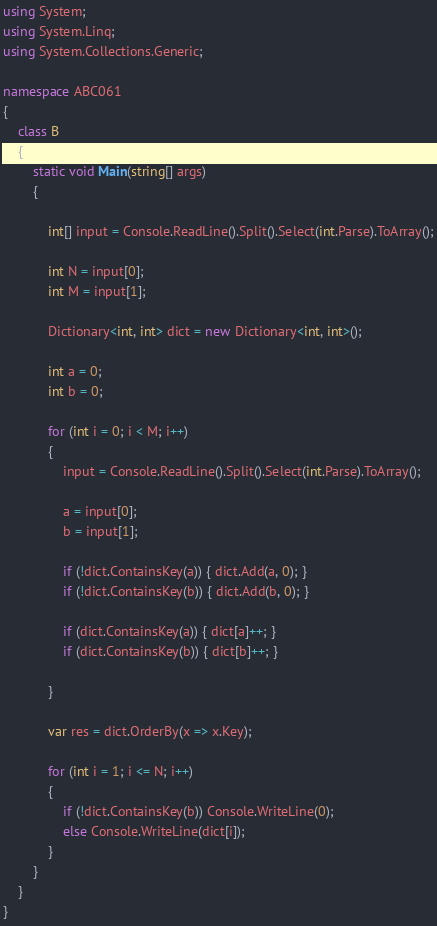<code> <loc_0><loc_0><loc_500><loc_500><_C#_>using System;
using System.Linq;
using System.Collections.Generic;

namespace ABC061
{
    class B
    {
        static void Main(string[] args)
        {

            int[] input = Console.ReadLine().Split().Select(int.Parse).ToArray();

            int N = input[0];
            int M = input[1];

            Dictionary<int, int> dict = new Dictionary<int, int>();

            int a = 0;
            int b = 0;

            for (int i = 0; i < M; i++)
            {
                input = Console.ReadLine().Split().Select(int.Parse).ToArray();

                a = input[0];
                b = input[1];

                if (!dict.ContainsKey(a)) { dict.Add(a, 0); }
                if (!dict.ContainsKey(b)) { dict.Add(b, 0); }

                if (dict.ContainsKey(a)) { dict[a]++; }
                if (dict.ContainsKey(b)) { dict[b]++; }

            }

            var res = dict.OrderBy(x => x.Key);

            for (int i = 1; i <= N; i++)
            {
                if (!dict.ContainsKey(b)) Console.WriteLine(0);
                else Console.WriteLine(dict[i]);
            }
        }
    }
}
</code> 